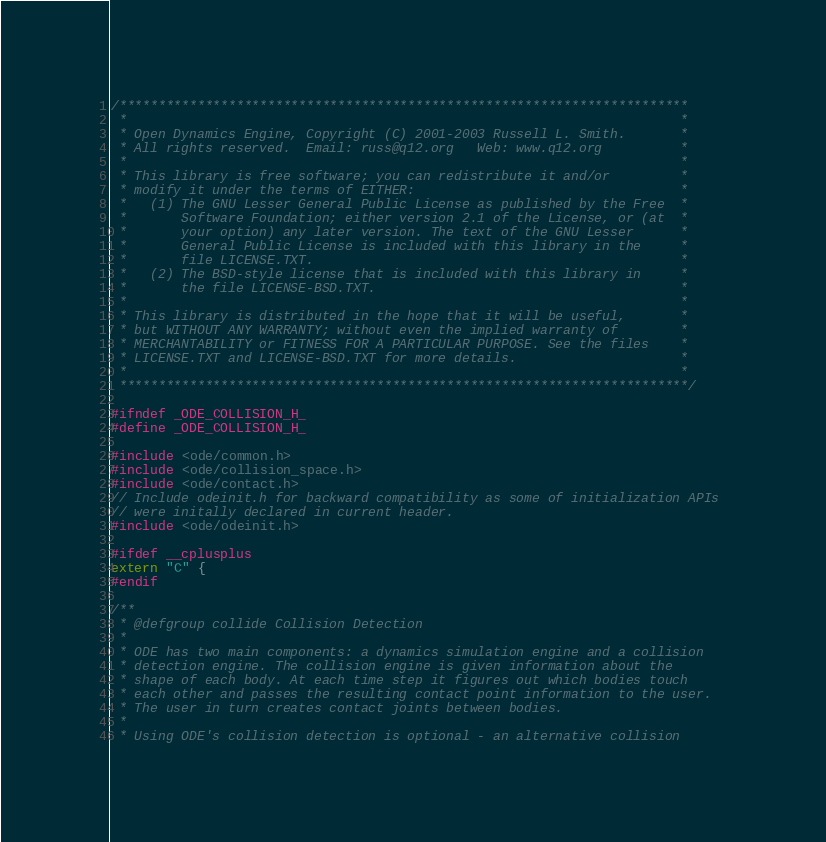<code> <loc_0><loc_0><loc_500><loc_500><_C_>/*************************************************************************
 *                                                                       *
 * Open Dynamics Engine, Copyright (C) 2001-2003 Russell L. Smith.       *
 * All rights reserved.  Email: russ@q12.org   Web: www.q12.org          *
 *                                                                       *
 * This library is free software; you can redistribute it and/or         *
 * modify it under the terms of EITHER:                                  *
 *   (1) The GNU Lesser General Public License as published by the Free  *
 *       Software Foundation; either version 2.1 of the License, or (at  *
 *       your option) any later version. The text of the GNU Lesser      *
 *       General Public License is included with this library in the     *
 *       file LICENSE.TXT.                                               *
 *   (2) The BSD-style license that is included with this library in     *
 *       the file LICENSE-BSD.TXT.                                       *
 *                                                                       *
 * This library is distributed in the hope that it will be useful,       *
 * but WITHOUT ANY WARRANTY; without even the implied warranty of        *
 * MERCHANTABILITY or FITNESS FOR A PARTICULAR PURPOSE. See the files    *
 * LICENSE.TXT and LICENSE-BSD.TXT for more details.                     *
 *                                                                       *
 *************************************************************************/

#ifndef _ODE_COLLISION_H_
#define _ODE_COLLISION_H_

#include <ode/common.h>
#include <ode/collision_space.h>
#include <ode/contact.h>
// Include odeinit.h for backward compatibility as some of initialization APIs 
// were initally declared in current header.
#include <ode/odeinit.h>

#ifdef __cplusplus
extern "C" {
#endif

/**
 * @defgroup collide Collision Detection
 *
 * ODE has two main components: a dynamics simulation engine and a collision
 * detection engine. The collision engine is given information about the
 * shape of each body. At each time step it figures out which bodies touch
 * each other and passes the resulting contact point information to the user.
 * The user in turn creates contact joints between bodies.
 *
 * Using ODE's collision detection is optional - an alternative collision</code> 